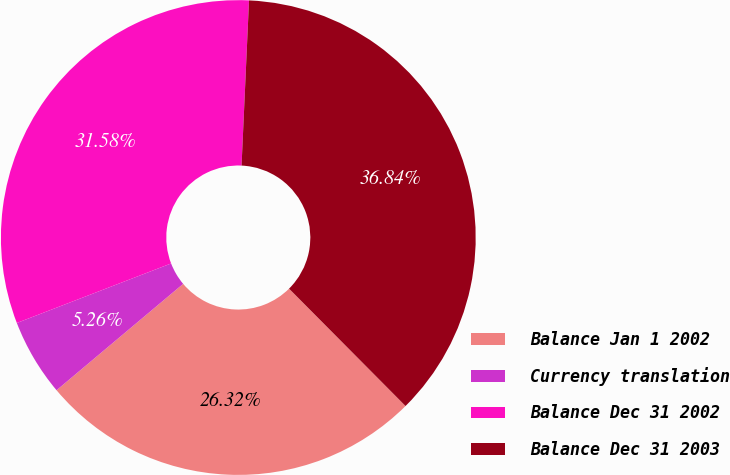Convert chart. <chart><loc_0><loc_0><loc_500><loc_500><pie_chart><fcel>Balance Jan 1 2002<fcel>Currency translation<fcel>Balance Dec 31 2002<fcel>Balance Dec 31 2003<nl><fcel>26.32%<fcel>5.26%<fcel>31.58%<fcel>36.84%<nl></chart> 